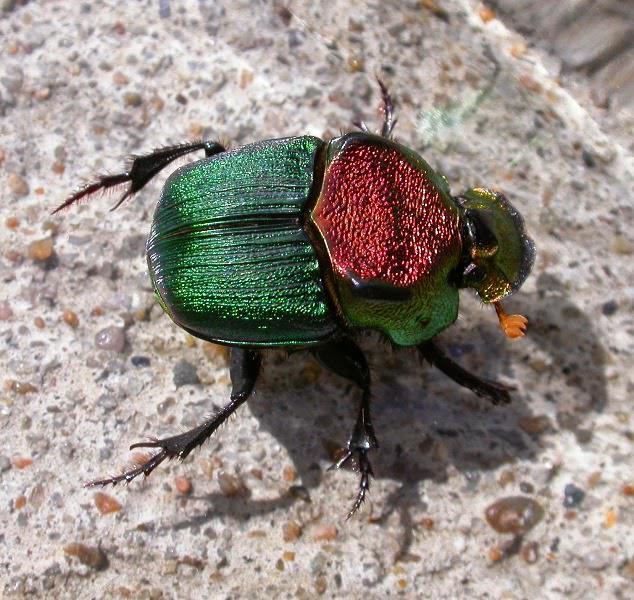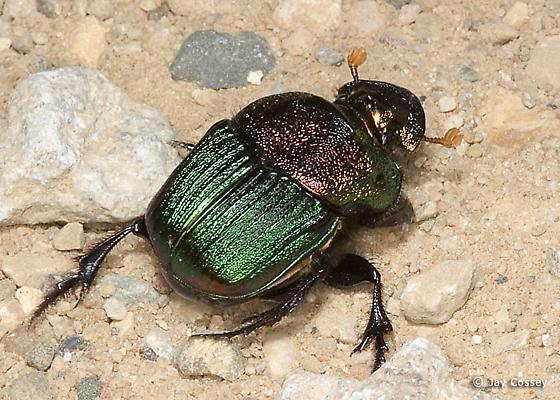The first image is the image on the left, the second image is the image on the right. Evaluate the accuracy of this statement regarding the images: "All of the bugs are greenish in color.". Is it true? Answer yes or no. Yes. 